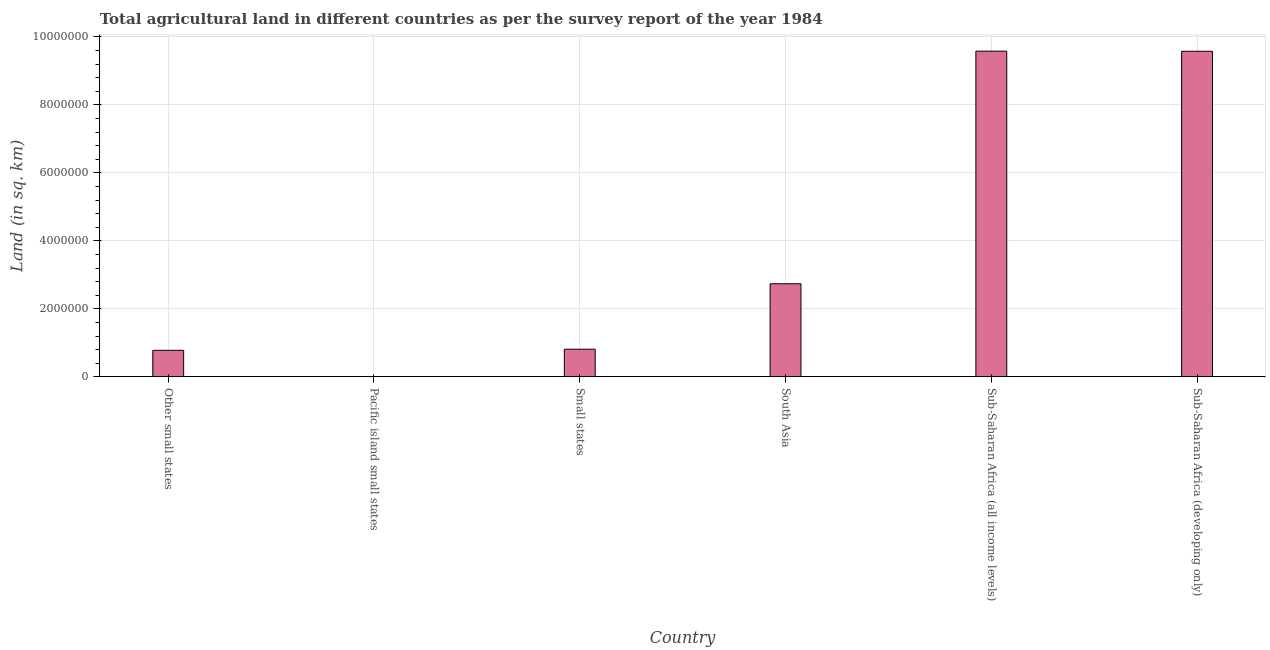Does the graph contain grids?
Your answer should be very brief. Yes. What is the title of the graph?
Keep it short and to the point. Total agricultural land in different countries as per the survey report of the year 1984. What is the label or title of the X-axis?
Make the answer very short. Country. What is the label or title of the Y-axis?
Your response must be concise. Land (in sq. km). What is the agricultural land in Small states?
Your answer should be compact. 8.14e+05. Across all countries, what is the maximum agricultural land?
Your answer should be very brief. 9.58e+06. Across all countries, what is the minimum agricultural land?
Your answer should be very brief. 6810. In which country was the agricultural land maximum?
Your answer should be compact. Sub-Saharan Africa (all income levels). In which country was the agricultural land minimum?
Provide a succinct answer. Pacific island small states. What is the sum of the agricultural land?
Your response must be concise. 2.35e+07. What is the difference between the agricultural land in Other small states and Sub-Saharan Africa (developing only)?
Your answer should be compact. -8.80e+06. What is the average agricultural land per country?
Your response must be concise. 3.92e+06. What is the median agricultural land?
Ensure brevity in your answer.  1.78e+06. In how many countries, is the agricultural land greater than 9200000 sq. km?
Make the answer very short. 2. What is the ratio of the agricultural land in Small states to that in Sub-Saharan Africa (all income levels)?
Provide a short and direct response. 0.09. What is the difference between the highest and the second highest agricultural land?
Your answer should be compact. 3400. What is the difference between the highest and the lowest agricultural land?
Your answer should be compact. 9.58e+06. What is the difference between two consecutive major ticks on the Y-axis?
Provide a short and direct response. 2.00e+06. What is the Land (in sq. km) in Other small states?
Provide a succinct answer. 7.81e+05. What is the Land (in sq. km) in Pacific island small states?
Your answer should be very brief. 6810. What is the Land (in sq. km) in Small states?
Offer a very short reply. 8.14e+05. What is the Land (in sq. km) in South Asia?
Ensure brevity in your answer.  2.74e+06. What is the Land (in sq. km) of Sub-Saharan Africa (all income levels)?
Your answer should be very brief. 9.58e+06. What is the Land (in sq. km) of Sub-Saharan Africa (developing only)?
Ensure brevity in your answer.  9.58e+06. What is the difference between the Land (in sq. km) in Other small states and Pacific island small states?
Ensure brevity in your answer.  7.74e+05. What is the difference between the Land (in sq. km) in Other small states and Small states?
Your response must be concise. -3.25e+04. What is the difference between the Land (in sq. km) in Other small states and South Asia?
Provide a short and direct response. -1.96e+06. What is the difference between the Land (in sq. km) in Other small states and Sub-Saharan Africa (all income levels)?
Provide a short and direct response. -8.80e+06. What is the difference between the Land (in sq. km) in Other small states and Sub-Saharan Africa (developing only)?
Give a very brief answer. -8.80e+06. What is the difference between the Land (in sq. km) in Pacific island small states and Small states?
Your answer should be very brief. -8.07e+05. What is the difference between the Land (in sq. km) in Pacific island small states and South Asia?
Give a very brief answer. -2.73e+06. What is the difference between the Land (in sq. km) in Pacific island small states and Sub-Saharan Africa (all income levels)?
Provide a short and direct response. -9.58e+06. What is the difference between the Land (in sq. km) in Pacific island small states and Sub-Saharan Africa (developing only)?
Give a very brief answer. -9.57e+06. What is the difference between the Land (in sq. km) in Small states and South Asia?
Make the answer very short. -1.93e+06. What is the difference between the Land (in sq. km) in Small states and Sub-Saharan Africa (all income levels)?
Your answer should be compact. -8.77e+06. What is the difference between the Land (in sq. km) in Small states and Sub-Saharan Africa (developing only)?
Give a very brief answer. -8.77e+06. What is the difference between the Land (in sq. km) in South Asia and Sub-Saharan Africa (all income levels)?
Make the answer very short. -6.84e+06. What is the difference between the Land (in sq. km) in South Asia and Sub-Saharan Africa (developing only)?
Ensure brevity in your answer.  -6.84e+06. What is the difference between the Land (in sq. km) in Sub-Saharan Africa (all income levels) and Sub-Saharan Africa (developing only)?
Offer a very short reply. 3400. What is the ratio of the Land (in sq. km) in Other small states to that in Pacific island small states?
Offer a terse response. 114.7. What is the ratio of the Land (in sq. km) in Other small states to that in Small states?
Provide a short and direct response. 0.96. What is the ratio of the Land (in sq. km) in Other small states to that in South Asia?
Provide a short and direct response. 0.28. What is the ratio of the Land (in sq. km) in Other small states to that in Sub-Saharan Africa (all income levels)?
Your response must be concise. 0.08. What is the ratio of the Land (in sq. km) in Other small states to that in Sub-Saharan Africa (developing only)?
Offer a terse response. 0.08. What is the ratio of the Land (in sq. km) in Pacific island small states to that in Small states?
Provide a short and direct response. 0.01. What is the ratio of the Land (in sq. km) in Pacific island small states to that in South Asia?
Your answer should be compact. 0. What is the ratio of the Land (in sq. km) in Pacific island small states to that in Sub-Saharan Africa (all income levels)?
Provide a short and direct response. 0. What is the ratio of the Land (in sq. km) in Pacific island small states to that in Sub-Saharan Africa (developing only)?
Provide a short and direct response. 0. What is the ratio of the Land (in sq. km) in Small states to that in South Asia?
Your answer should be compact. 0.3. What is the ratio of the Land (in sq. km) in Small states to that in Sub-Saharan Africa (all income levels)?
Offer a terse response. 0.09. What is the ratio of the Land (in sq. km) in Small states to that in Sub-Saharan Africa (developing only)?
Your answer should be very brief. 0.09. What is the ratio of the Land (in sq. km) in South Asia to that in Sub-Saharan Africa (all income levels)?
Your answer should be compact. 0.29. What is the ratio of the Land (in sq. km) in South Asia to that in Sub-Saharan Africa (developing only)?
Provide a short and direct response. 0.29. What is the ratio of the Land (in sq. km) in Sub-Saharan Africa (all income levels) to that in Sub-Saharan Africa (developing only)?
Offer a very short reply. 1. 